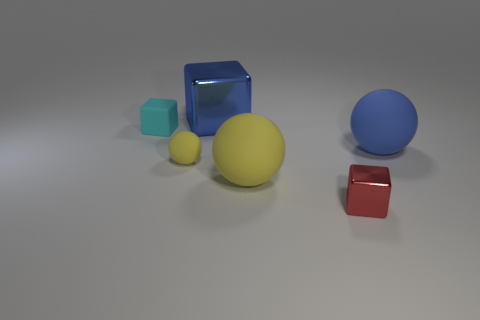There is a large blue thing that is the same material as the tiny red block; what is its shape?
Keep it short and to the point. Cube. Is there anything else that is the same shape as the big yellow object?
Your answer should be compact. Yes. There is a tiny yellow object; what number of shiny things are in front of it?
Make the answer very short. 1. Are there the same number of tiny red metal cubes that are on the right side of the blue block and cyan objects?
Offer a terse response. Yes. Does the tiny cyan block have the same material as the big yellow thing?
Your answer should be compact. Yes. What is the size of the matte object that is both to the left of the red metal cube and behind the tiny yellow thing?
Give a very brief answer. Small. What number of matte things are the same size as the cyan block?
Offer a very short reply. 1. How big is the cyan matte block on the left side of the large blue thing that is to the right of the blue shiny cube?
Offer a very short reply. Small. Do the matte thing that is on the right side of the tiny shiny object and the shiny object behind the small matte ball have the same shape?
Keep it short and to the point. No. There is a thing that is behind the blue sphere and left of the blue metal object; what color is it?
Offer a terse response. Cyan. 